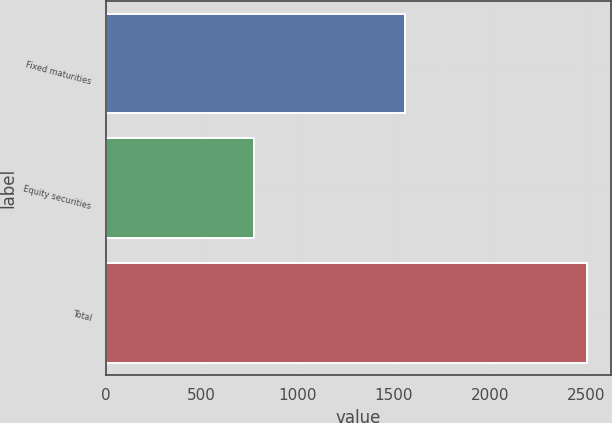Convert chart. <chart><loc_0><loc_0><loc_500><loc_500><bar_chart><fcel>Fixed maturities<fcel>Equity securities<fcel>Total<nl><fcel>1560<fcel>774<fcel>2507<nl></chart> 